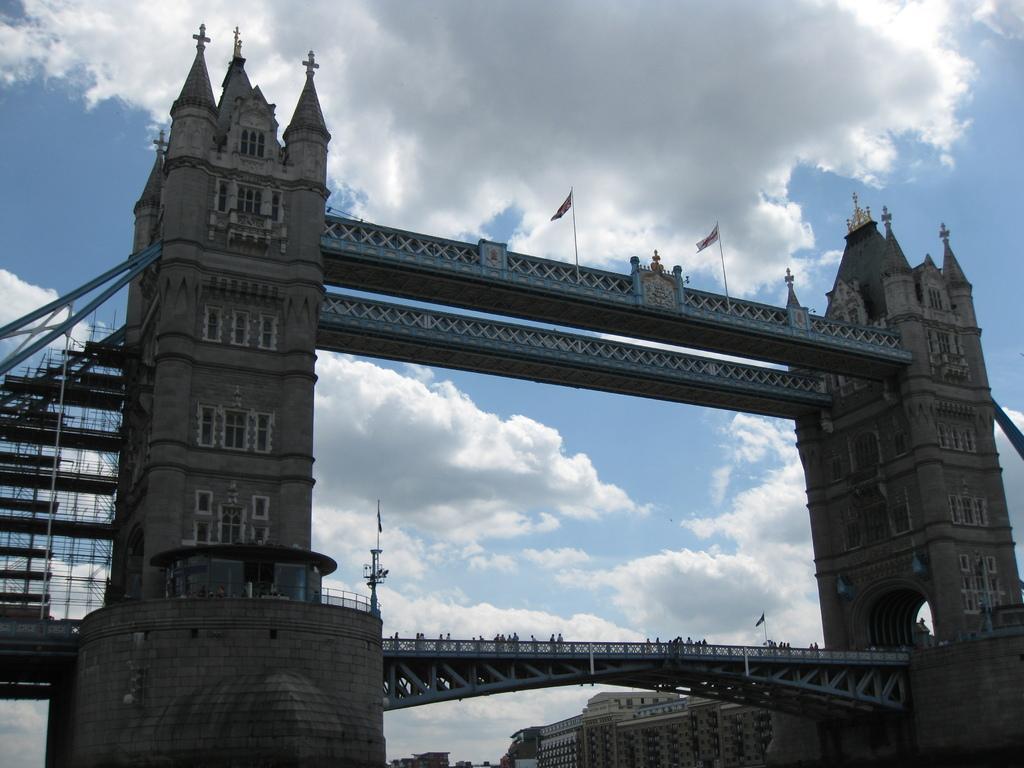Can you describe this image briefly? In this image I can see the bridge and there are flags in the top. I can see few people behind the railing. In the background I can see the building, clouds and the blue sky. 